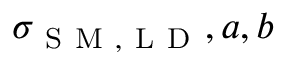<formula> <loc_0><loc_0><loc_500><loc_500>\sigma _ { S M , L D } , a , b</formula> 